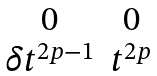Convert formula to latex. <formula><loc_0><loc_0><loc_500><loc_500>\begin{matrix} 0 & 0 \\ \delta t ^ { 2 p - 1 } & t ^ { 2 p } \\ \end{matrix}</formula> 